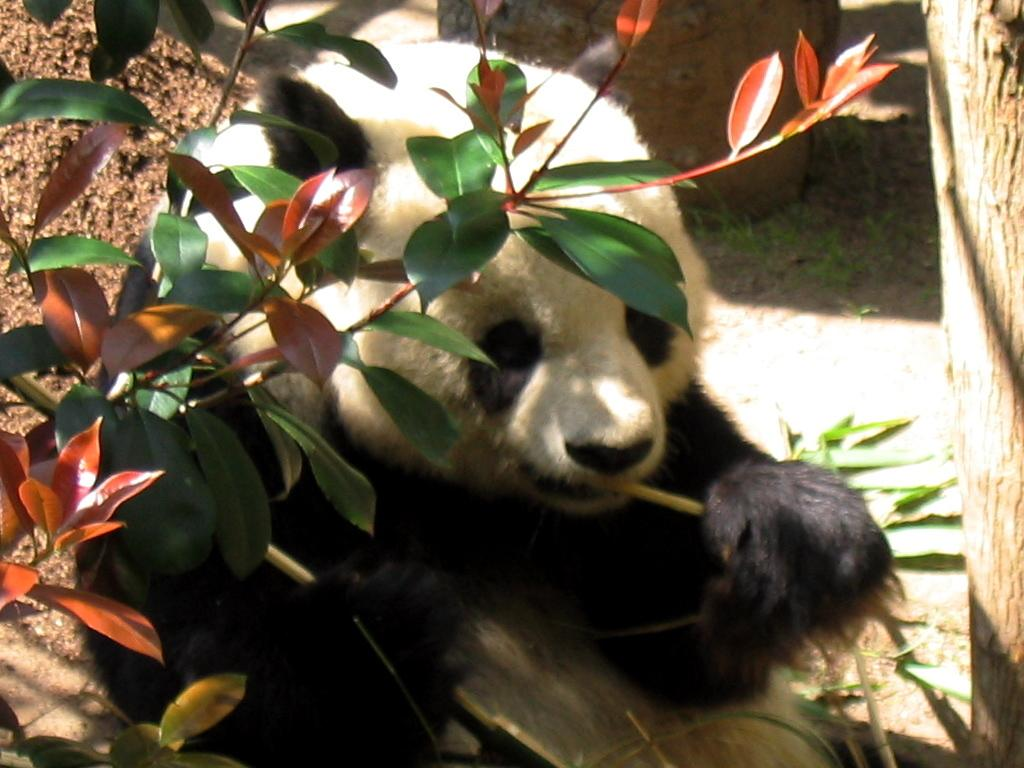What is the main subject in the center of the image? There is a panda in the center of the image. What type of vegetation can be seen in the image? There are trees in the image. What month is depicted in the image? The image does not depict a specific month; it features a panda and trees. Can you see a church in the image? There is no church present in the image. 